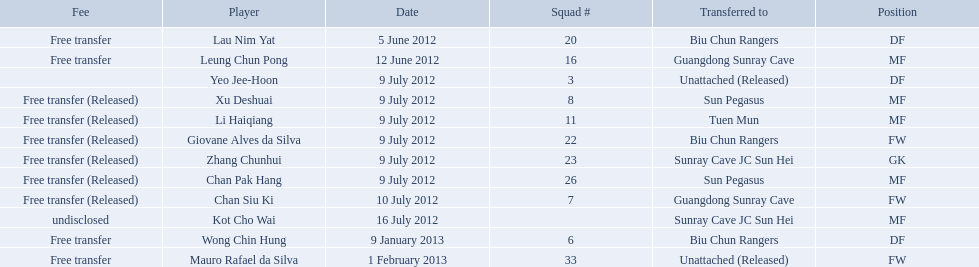Which players are listed? Lau Nim Yat, Leung Chun Pong, Yeo Jee-Hoon, Xu Deshuai, Li Haiqiang, Giovane Alves da Silva, Zhang Chunhui, Chan Pak Hang, Chan Siu Ki, Kot Cho Wai, Wong Chin Hung, Mauro Rafael da Silva. Which dates were players transferred to the biu chun rangers? 5 June 2012, 9 July 2012, 9 January 2013. Of those which is the date for wong chin hung? 9 January 2013. 